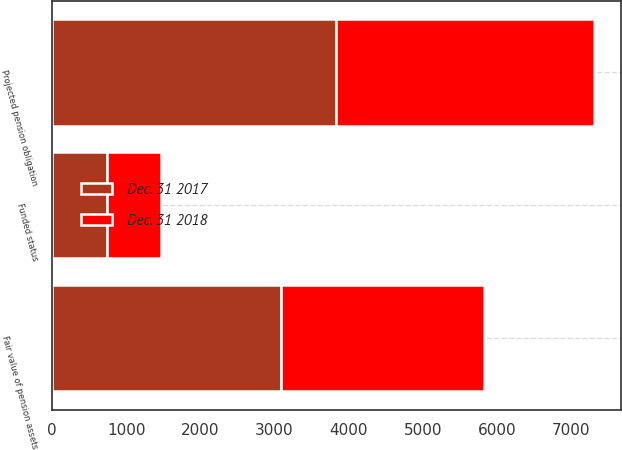Convert chart. <chart><loc_0><loc_0><loc_500><loc_500><stacked_bar_chart><ecel><fcel>Fair value of pension assets<fcel>Projected pension obligation<fcel>Funded status<nl><fcel>Dec. 31 2018<fcel>2742<fcel>3477<fcel>735<nl><fcel>Dec. 31 2017<fcel>3088<fcel>3828<fcel>740<nl></chart> 